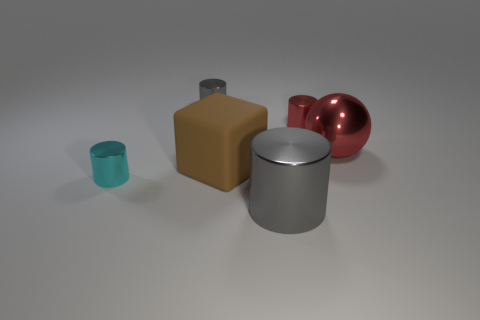How would you describe the lighting and shadow in this scene? The lighting in the scene appears to be diffused, with a soft shadow cast underneath each object. This suggests an even distribution of light coming from above, possibly from multiple angles. The shadows are soft-edged and elongated, indicating the light source is not very close to the objects, creating a calm and balanced setting. Do the shadows tell us anything about the texture of the surface they're on? Indeed, the shadows provide clues about the texture. Given their soft and slightly fuzzy appearance, we can infer that the surface is likely matte or has a very slight texture to it, which diffuses the light and softens the shadow edges, as opposed to a highly reflective surface that would yield sharper, clearer shadows. 